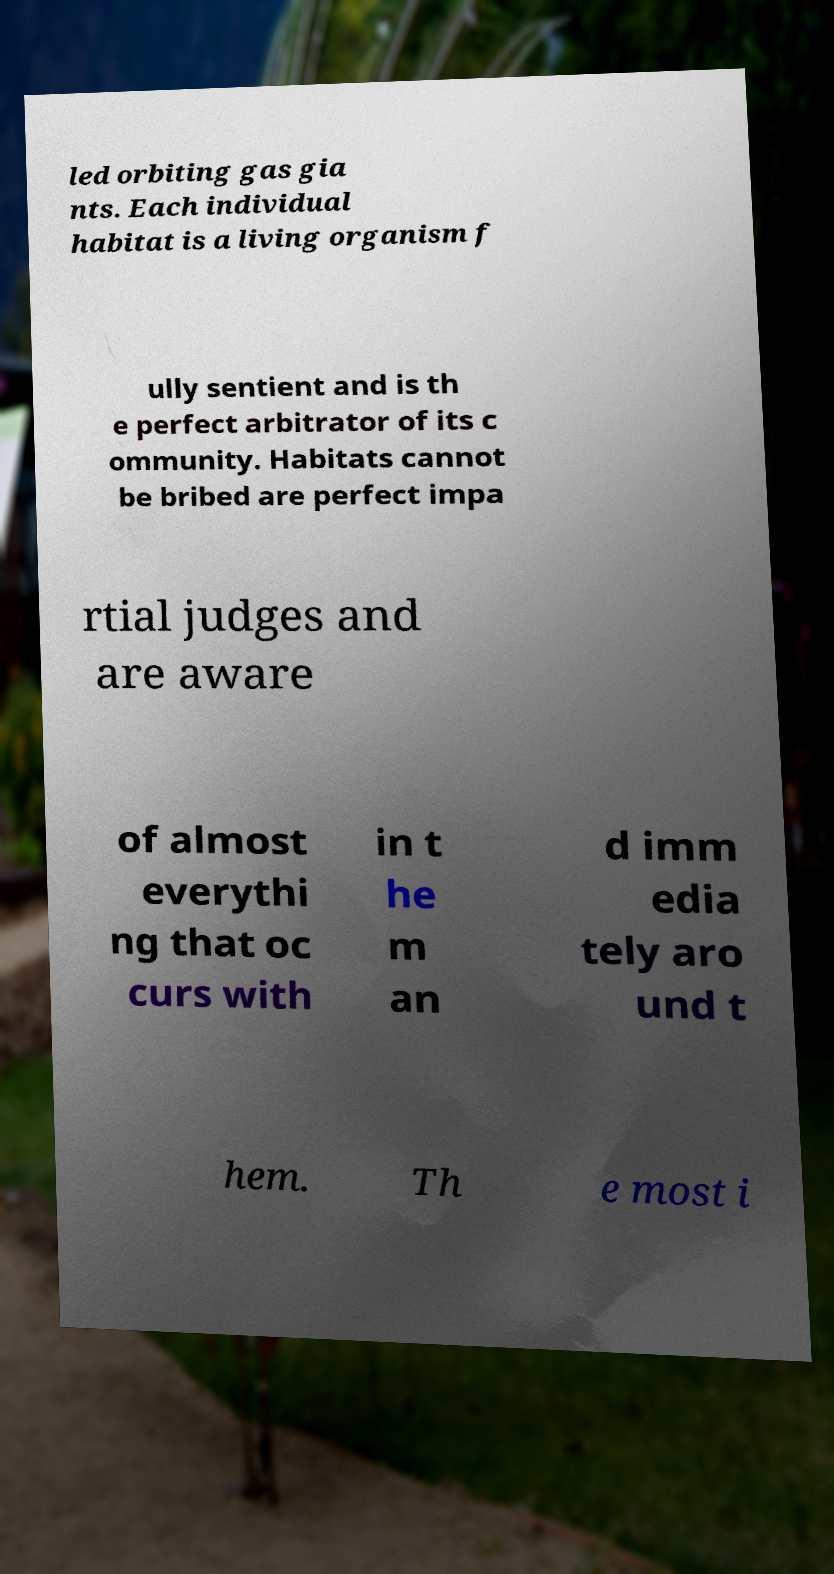Please identify and transcribe the text found in this image. led orbiting gas gia nts. Each individual habitat is a living organism f ully sentient and is th e perfect arbitrator of its c ommunity. Habitats cannot be bribed are perfect impa rtial judges and are aware of almost everythi ng that oc curs with in t he m an d imm edia tely aro und t hem. Th e most i 